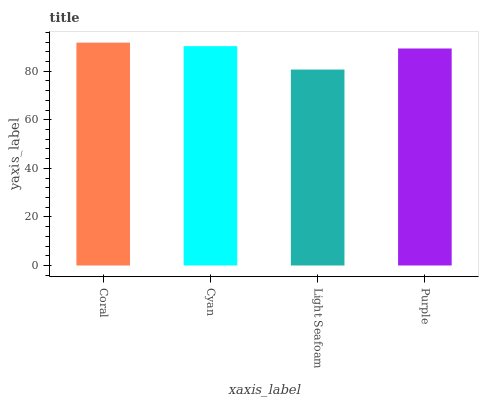Is Light Seafoam the minimum?
Answer yes or no. Yes. Is Coral the maximum?
Answer yes or no. Yes. Is Cyan the minimum?
Answer yes or no. No. Is Cyan the maximum?
Answer yes or no. No. Is Coral greater than Cyan?
Answer yes or no. Yes. Is Cyan less than Coral?
Answer yes or no. Yes. Is Cyan greater than Coral?
Answer yes or no. No. Is Coral less than Cyan?
Answer yes or no. No. Is Cyan the high median?
Answer yes or no. Yes. Is Purple the low median?
Answer yes or no. Yes. Is Purple the high median?
Answer yes or no. No. Is Cyan the low median?
Answer yes or no. No. 